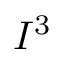<formula> <loc_0><loc_0><loc_500><loc_500>I ^ { 3 }</formula> 